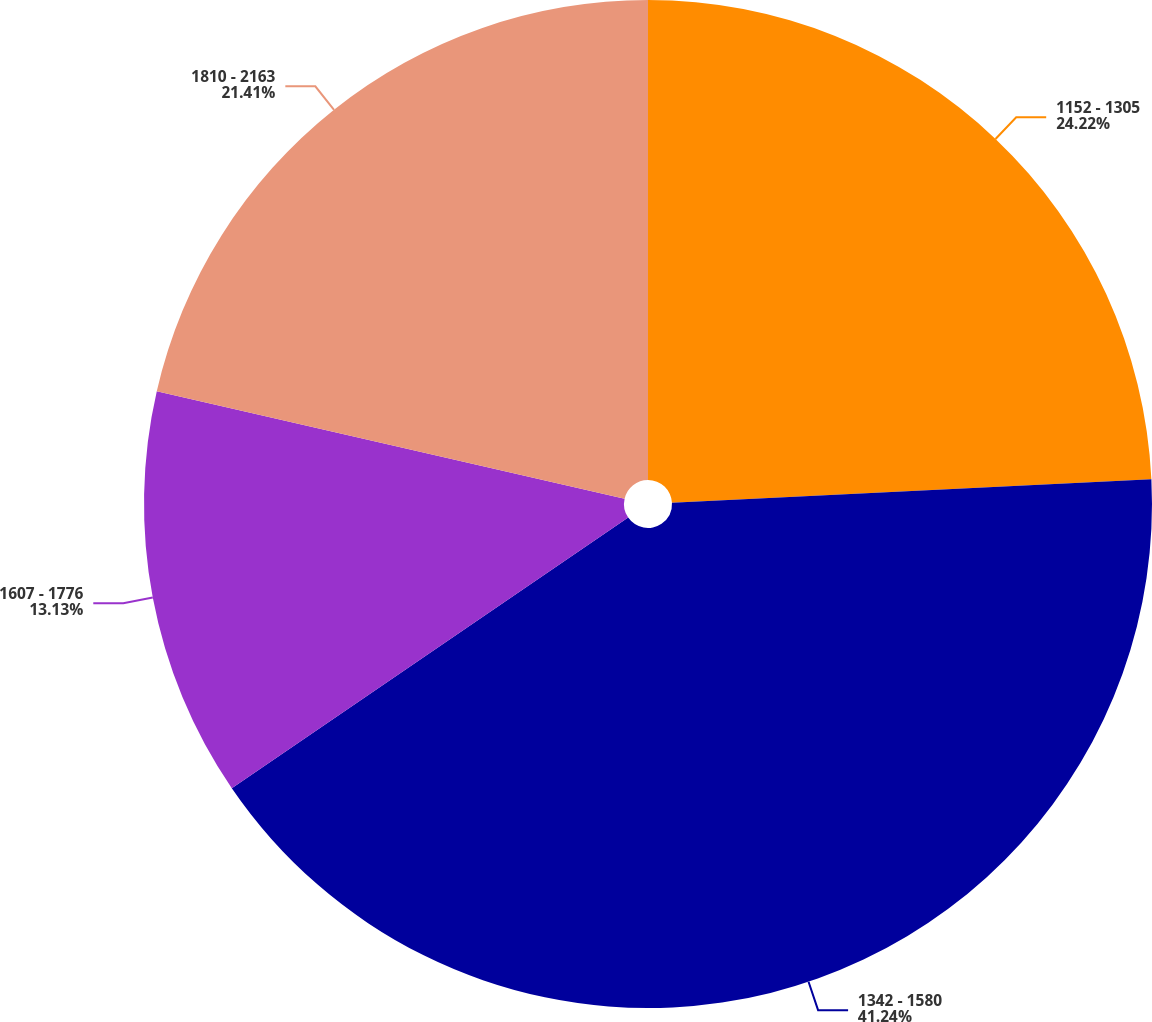<chart> <loc_0><loc_0><loc_500><loc_500><pie_chart><fcel>1152 - 1305<fcel>1342 - 1580<fcel>1607 - 1776<fcel>1810 - 2163<nl><fcel>24.22%<fcel>41.25%<fcel>13.13%<fcel>21.41%<nl></chart> 